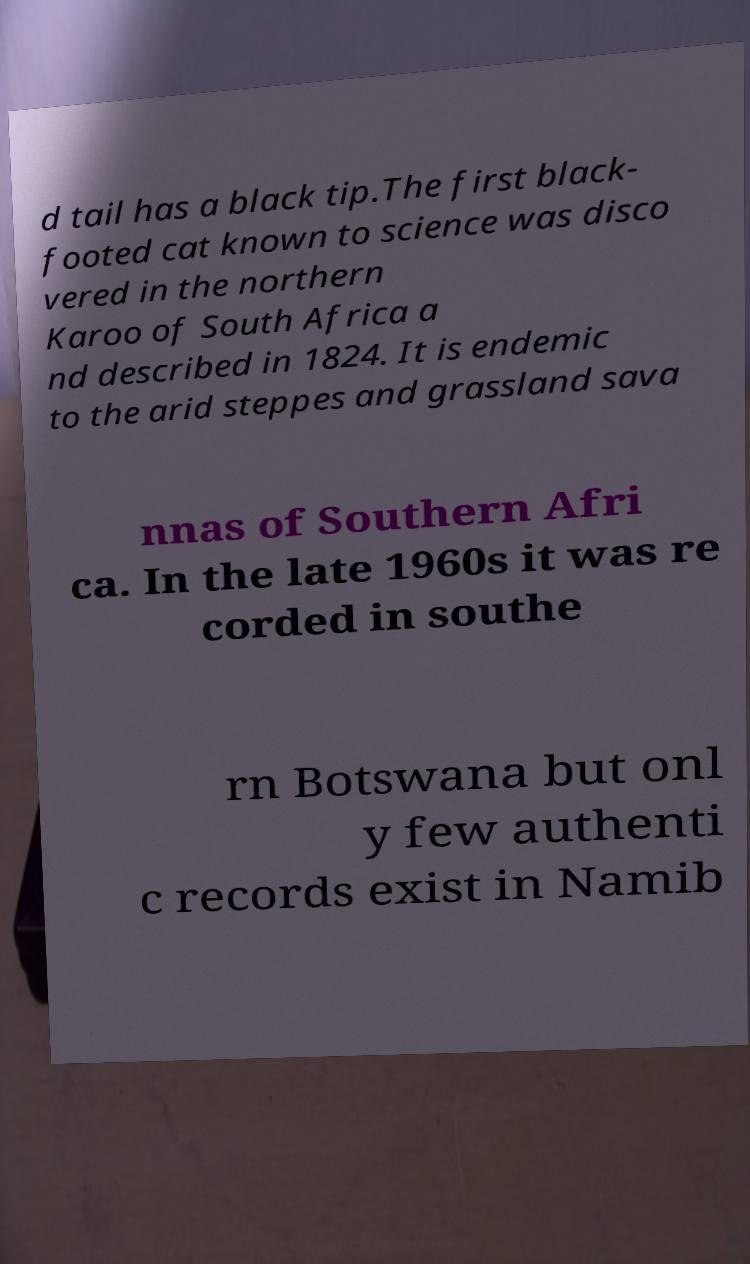What messages or text are displayed in this image? I need them in a readable, typed format. d tail has a black tip.The first black- footed cat known to science was disco vered in the northern Karoo of South Africa a nd described in 1824. It is endemic to the arid steppes and grassland sava nnas of Southern Afri ca. In the late 1960s it was re corded in southe rn Botswana but onl y few authenti c records exist in Namib 